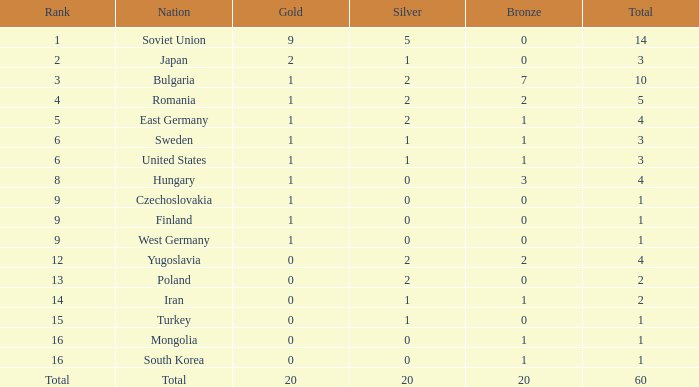What is the total number of golds having a total of 1, bronzes of 0, and from West Germany? 1.0. 